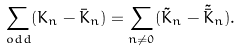<formula> <loc_0><loc_0><loc_500><loc_500>\sum _ { o d d } ( K _ { n } - \bar { K } _ { n } ) = \sum _ { n \neq 0 } ( \tilde { K } _ { n } - \tilde { \bar { K } } _ { n } ) .</formula> 